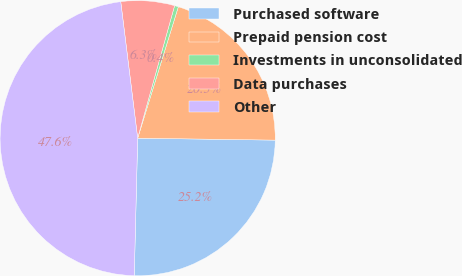Convert chart to OTSL. <chart><loc_0><loc_0><loc_500><loc_500><pie_chart><fcel>Purchased software<fcel>Prepaid pension cost<fcel>Investments in unconsolidated<fcel>Data purchases<fcel>Other<nl><fcel>25.17%<fcel>20.45%<fcel>0.45%<fcel>6.29%<fcel>47.64%<nl></chart> 